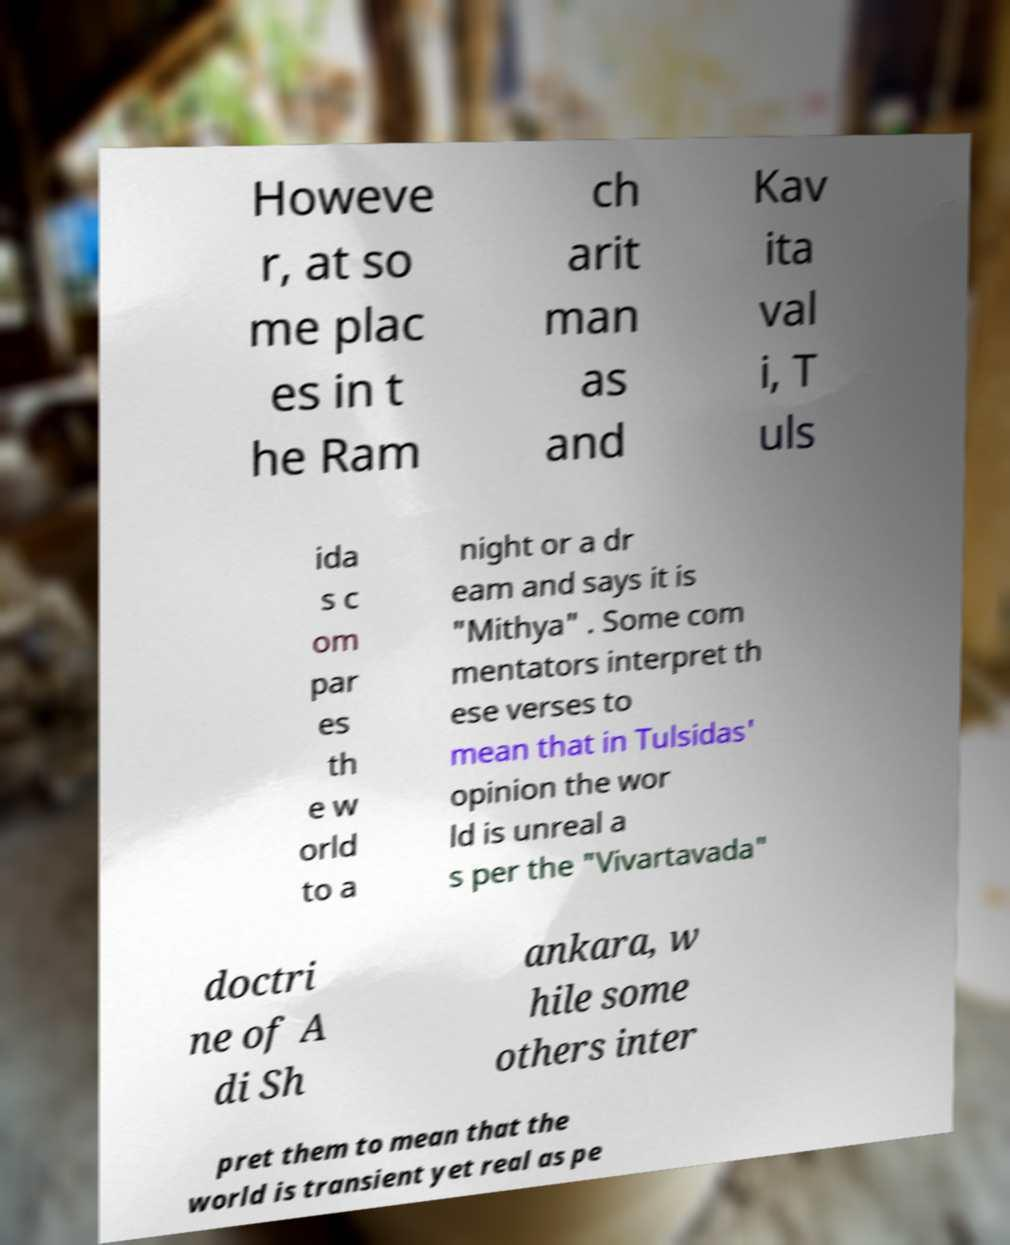Please identify and transcribe the text found in this image. Howeve r, at so me plac es in t he Ram ch arit man as and Kav ita val i, T uls ida s c om par es th e w orld to a night or a dr eam and says it is "Mithya" . Some com mentators interpret th ese verses to mean that in Tulsidas' opinion the wor ld is unreal a s per the "Vivartavada" doctri ne of A di Sh ankara, w hile some others inter pret them to mean that the world is transient yet real as pe 